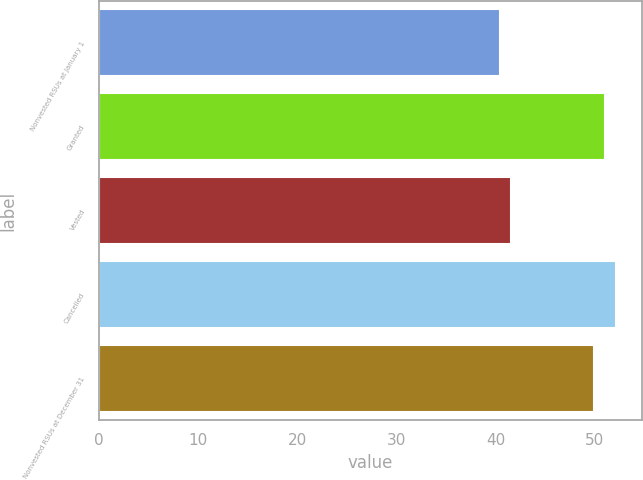Convert chart to OTSL. <chart><loc_0><loc_0><loc_500><loc_500><bar_chart><fcel>Nonvested RSUs at January 1<fcel>Granted<fcel>Vested<fcel>Cancelled<fcel>Nonvested RSUs at December 31<nl><fcel>40.45<fcel>51.06<fcel>41.51<fcel>52.12<fcel>49.89<nl></chart> 